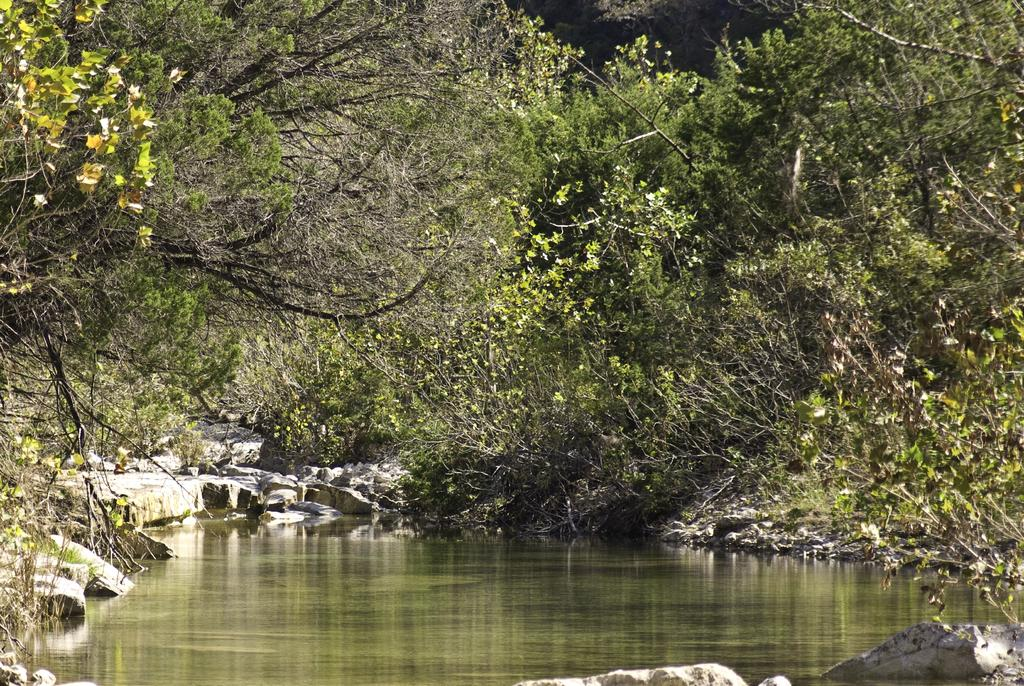What type of natural elements can be seen in the image? There are rocks, water, and trees visible in the image. Can you describe the water in the image? The water is visible in the image, but its specific characteristics are not mentioned in the facts. What type of vegetation is present in the image? Trees are present in the image. What type of plastic objects can be seen in the image? There is no mention of plastic objects in the image, so we cannot determine if any are present. 